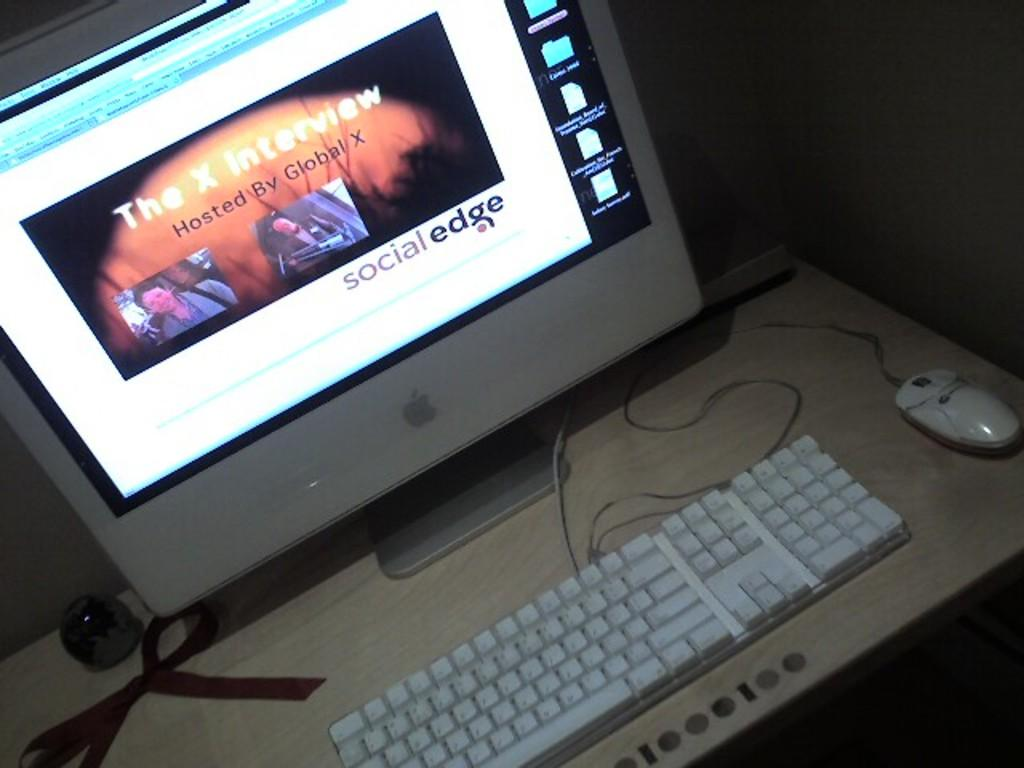<image>
Describe the image concisely. a computer with the words social edge written to the bottom right 